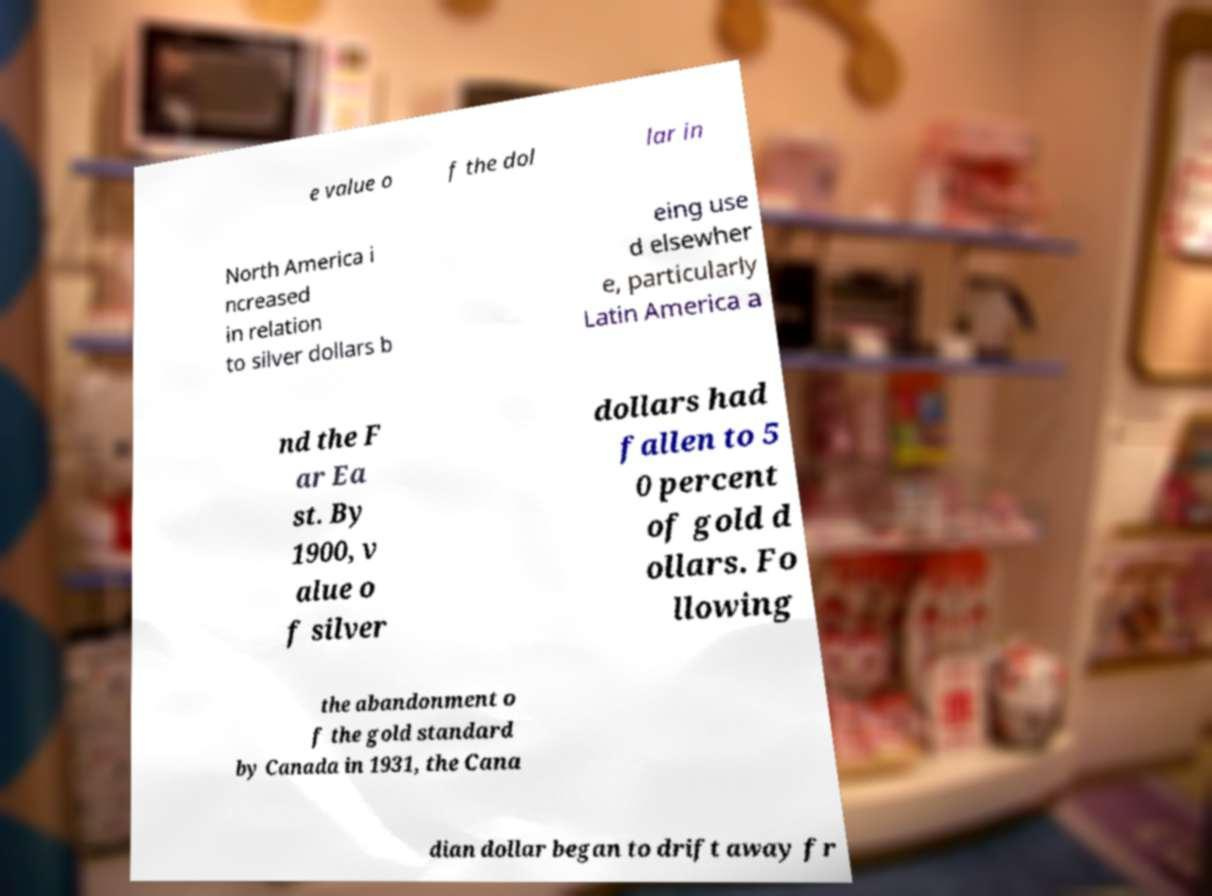I need the written content from this picture converted into text. Can you do that? e value o f the dol lar in North America i ncreased in relation to silver dollars b eing use d elsewher e, particularly Latin America a nd the F ar Ea st. By 1900, v alue o f silver dollars had fallen to 5 0 percent of gold d ollars. Fo llowing the abandonment o f the gold standard by Canada in 1931, the Cana dian dollar began to drift away fr 